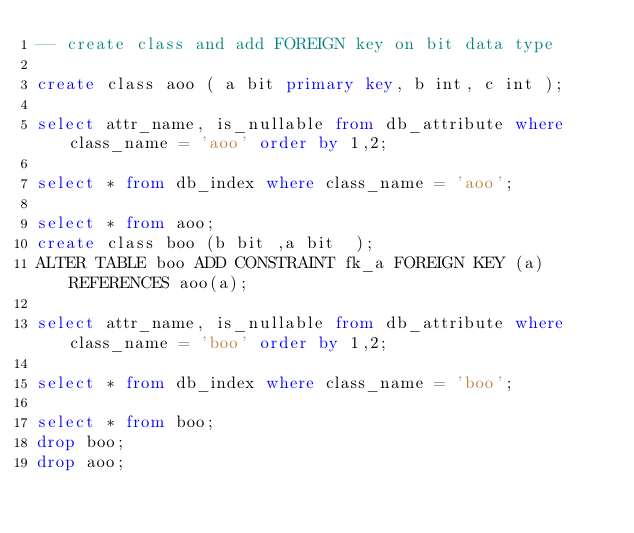<code> <loc_0><loc_0><loc_500><loc_500><_SQL_>-- create class and add FOREIGN key on bit data type

create class aoo ( a bit primary key, b int, c int );

select attr_name, is_nullable from db_attribute where class_name = 'aoo' order by 1,2;

select * from db_index where class_name = 'aoo';

select * from aoo;
create class boo (b bit ,a bit  );
ALTER TABLE boo ADD CONSTRAINT fk_a FOREIGN KEY (a) REFERENCES aoo(a);

select attr_name, is_nullable from db_attribute where class_name = 'boo' order by 1,2;

select * from db_index where class_name = 'boo';

select * from boo;
drop boo;
drop aoo;
</code> 